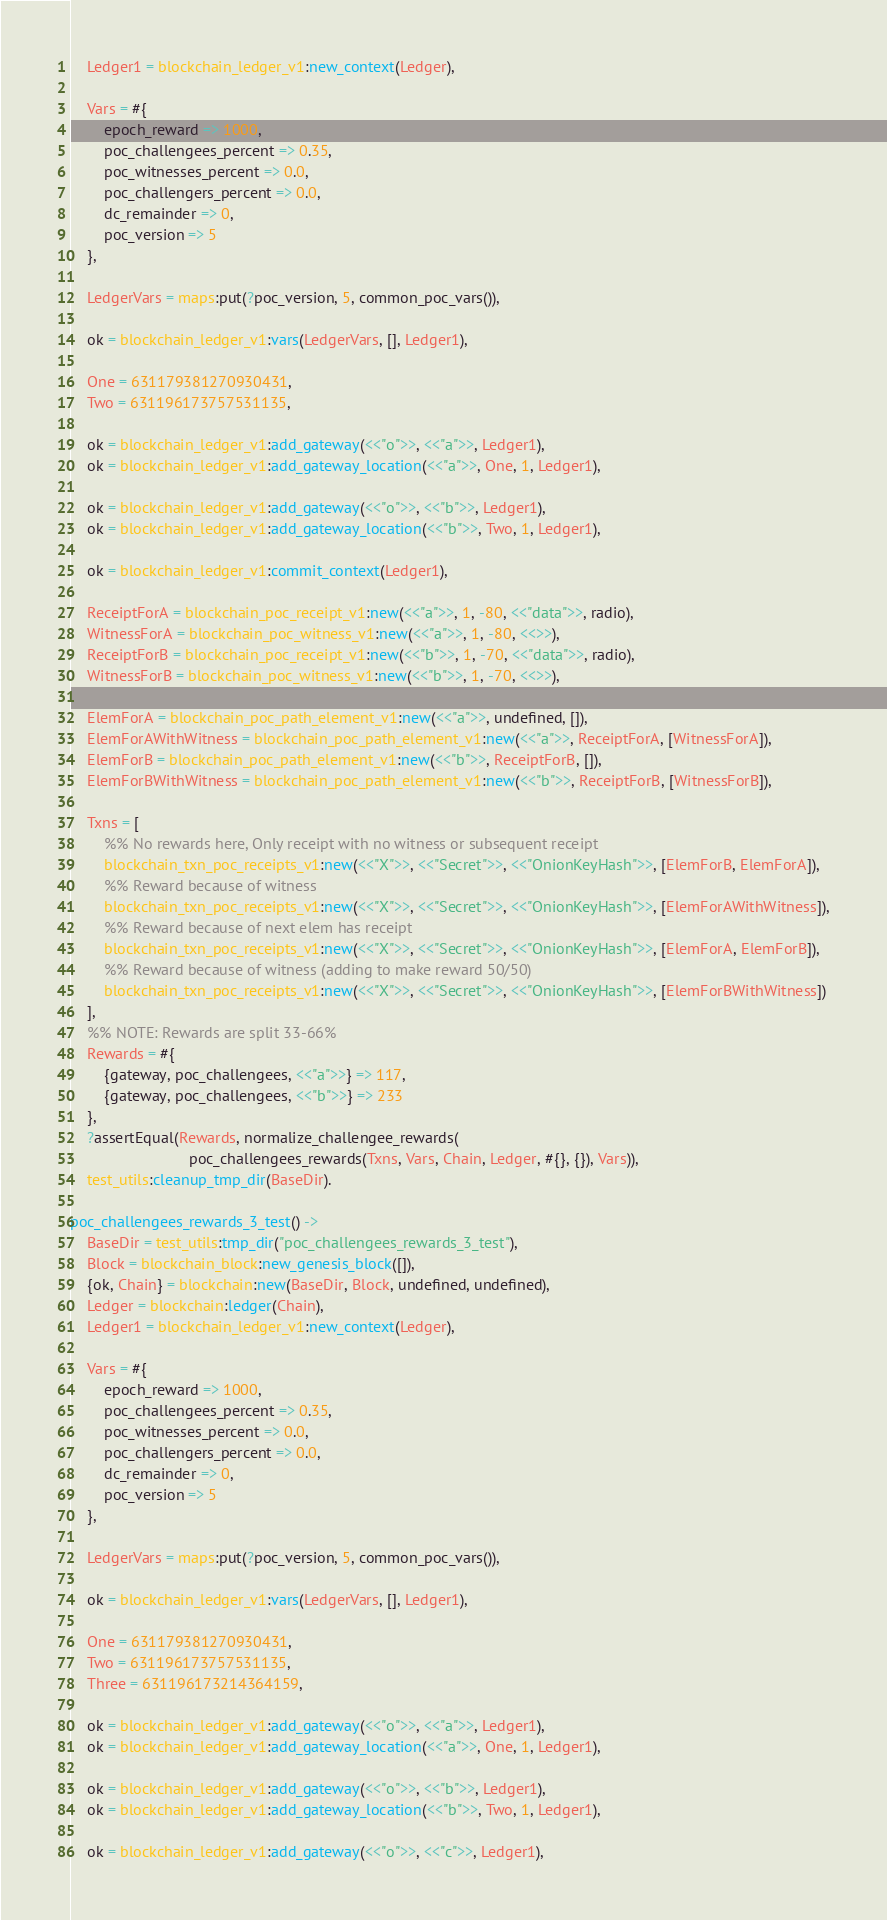Convert code to text. <code><loc_0><loc_0><loc_500><loc_500><_Erlang_>    Ledger1 = blockchain_ledger_v1:new_context(Ledger),

    Vars = #{
        epoch_reward => 1000,
        poc_challengees_percent => 0.35,
        poc_witnesses_percent => 0.0,
        poc_challengers_percent => 0.0,
        dc_remainder => 0,
        poc_version => 5
    },

    LedgerVars = maps:put(?poc_version, 5, common_poc_vars()),

    ok = blockchain_ledger_v1:vars(LedgerVars, [], Ledger1),

    One = 631179381270930431,
    Two = 631196173757531135,

    ok = blockchain_ledger_v1:add_gateway(<<"o">>, <<"a">>, Ledger1),
    ok = blockchain_ledger_v1:add_gateway_location(<<"a">>, One, 1, Ledger1),

    ok = blockchain_ledger_v1:add_gateway(<<"o">>, <<"b">>, Ledger1),
    ok = blockchain_ledger_v1:add_gateway_location(<<"b">>, Two, 1, Ledger1),

    ok = blockchain_ledger_v1:commit_context(Ledger1),

    ReceiptForA = blockchain_poc_receipt_v1:new(<<"a">>, 1, -80, <<"data">>, radio),
    WitnessForA = blockchain_poc_witness_v1:new(<<"a">>, 1, -80, <<>>),
    ReceiptForB = blockchain_poc_receipt_v1:new(<<"b">>, 1, -70, <<"data">>, radio),
    WitnessForB = blockchain_poc_witness_v1:new(<<"b">>, 1, -70, <<>>),

    ElemForA = blockchain_poc_path_element_v1:new(<<"a">>, undefined, []),
    ElemForAWithWitness = blockchain_poc_path_element_v1:new(<<"a">>, ReceiptForA, [WitnessForA]),
    ElemForB = blockchain_poc_path_element_v1:new(<<"b">>, ReceiptForB, []),
    ElemForBWithWitness = blockchain_poc_path_element_v1:new(<<"b">>, ReceiptForB, [WitnessForB]),

    Txns = [
        %% No rewards here, Only receipt with no witness or subsequent receipt
        blockchain_txn_poc_receipts_v1:new(<<"X">>, <<"Secret">>, <<"OnionKeyHash">>, [ElemForB, ElemForA]),
        %% Reward because of witness
        blockchain_txn_poc_receipts_v1:new(<<"X">>, <<"Secret">>, <<"OnionKeyHash">>, [ElemForAWithWitness]),
        %% Reward because of next elem has receipt
        blockchain_txn_poc_receipts_v1:new(<<"X">>, <<"Secret">>, <<"OnionKeyHash">>, [ElemForA, ElemForB]),
        %% Reward because of witness (adding to make reward 50/50)
        blockchain_txn_poc_receipts_v1:new(<<"X">>, <<"Secret">>, <<"OnionKeyHash">>, [ElemForBWithWitness])
    ],
    %% NOTE: Rewards are split 33-66%
    Rewards = #{
        {gateway, poc_challengees, <<"a">>} => 117,
        {gateway, poc_challengees, <<"b">>} => 233
    },
    ?assertEqual(Rewards, normalize_challengee_rewards(
                            poc_challengees_rewards(Txns, Vars, Chain, Ledger, #{}, {}), Vars)),
    test_utils:cleanup_tmp_dir(BaseDir).

poc_challengees_rewards_3_test() ->
    BaseDir = test_utils:tmp_dir("poc_challengees_rewards_3_test"),
    Block = blockchain_block:new_genesis_block([]),
    {ok, Chain} = blockchain:new(BaseDir, Block, undefined, undefined),
    Ledger = blockchain:ledger(Chain),
    Ledger1 = blockchain_ledger_v1:new_context(Ledger),

    Vars = #{
        epoch_reward => 1000,
        poc_challengees_percent => 0.35,
        poc_witnesses_percent => 0.0,
        poc_challengers_percent => 0.0,
        dc_remainder => 0,
        poc_version => 5
    },

    LedgerVars = maps:put(?poc_version, 5, common_poc_vars()),

    ok = blockchain_ledger_v1:vars(LedgerVars, [], Ledger1),

    One = 631179381270930431,
    Two = 631196173757531135,
    Three = 631196173214364159,

    ok = blockchain_ledger_v1:add_gateway(<<"o">>, <<"a">>, Ledger1),
    ok = blockchain_ledger_v1:add_gateway_location(<<"a">>, One, 1, Ledger1),

    ok = blockchain_ledger_v1:add_gateway(<<"o">>, <<"b">>, Ledger1),
    ok = blockchain_ledger_v1:add_gateway_location(<<"b">>, Two, 1, Ledger1),

    ok = blockchain_ledger_v1:add_gateway(<<"o">>, <<"c">>, Ledger1),</code> 